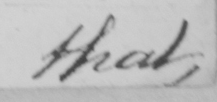What text is written in this handwritten line? that , 